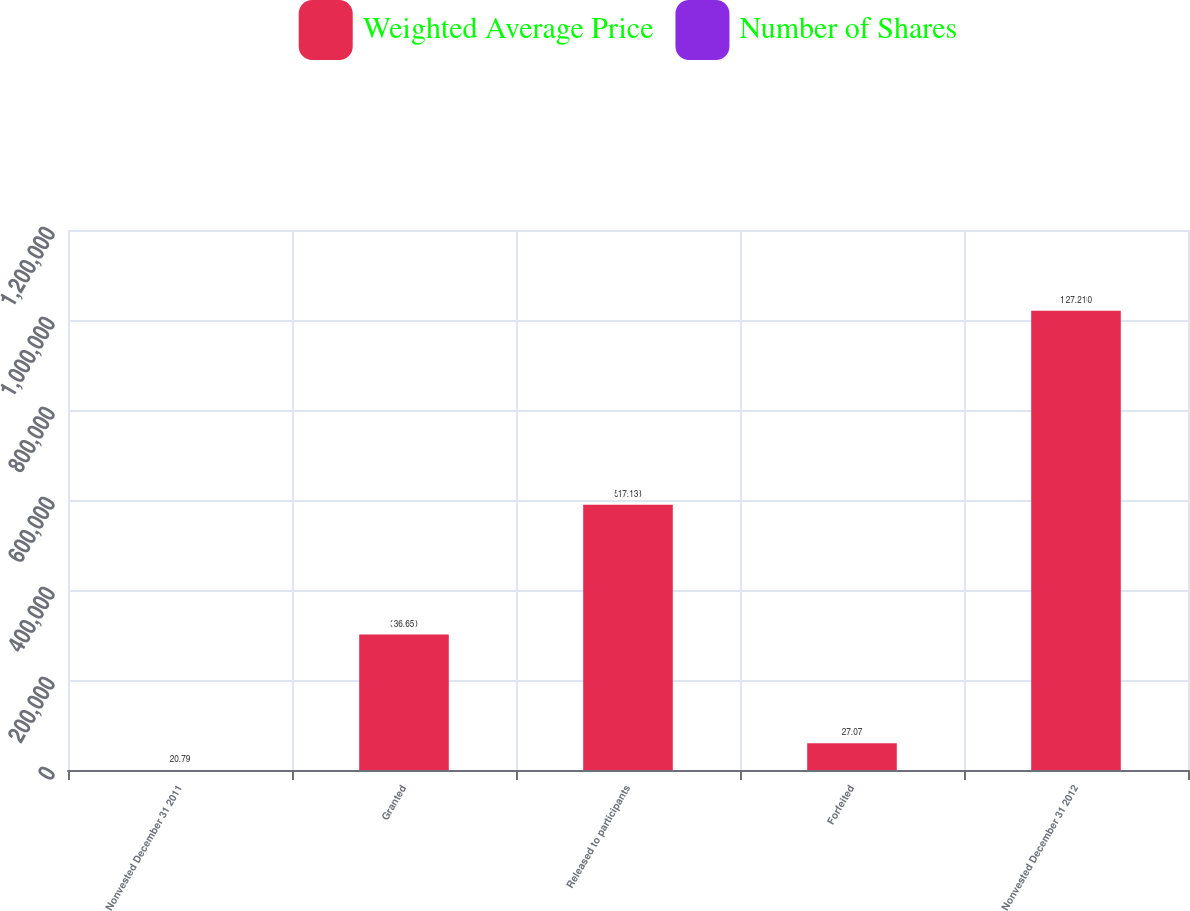Convert chart to OTSL. <chart><loc_0><loc_0><loc_500><loc_500><stacked_bar_chart><ecel><fcel>Nonvested December 31 2011<fcel>Granted<fcel>Released to participants<fcel>Forfeited<fcel>Nonvested December 31 2012<nl><fcel>Weighted Average Price<fcel>36.65<fcel>300950<fcel>589333<fcel>59691<fcel>1.0206e+06<nl><fcel>Number of Shares<fcel>20.79<fcel>36.65<fcel>17.13<fcel>27.07<fcel>27.21<nl></chart> 